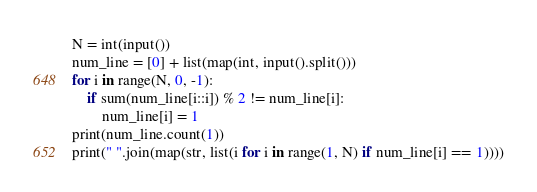Convert code to text. <code><loc_0><loc_0><loc_500><loc_500><_Python_>N = int(input())
num_line = [0] + list(map(int, input().split()))
for i in range(N, 0, -1):
    if sum(num_line[i::i]) % 2 != num_line[i]:
        num_line[i] = 1
print(num_line.count(1))
print(" ".join(map(str, list(i for i in range(1, N) if num_line[i] == 1))))</code> 